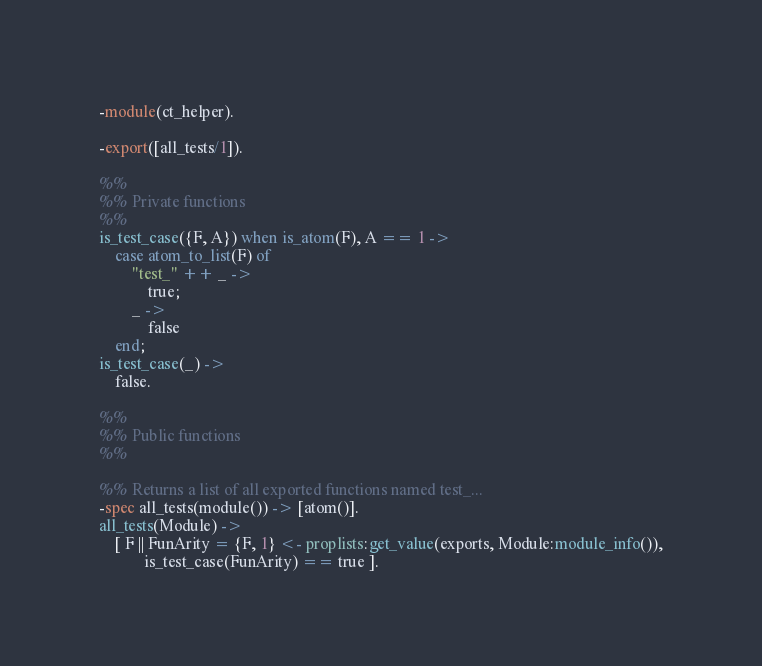<code> <loc_0><loc_0><loc_500><loc_500><_Erlang_>-module(ct_helper).

-export([all_tests/1]).

%%
%% Private functions
%%
is_test_case({F, A}) when is_atom(F), A == 1 ->
    case atom_to_list(F) of
        "test_" ++ _ ->
            true;
        _ ->
            false
    end;
is_test_case(_) ->
    false.

%%
%% Public functions
%%

%% Returns a list of all exported functions named test_...
-spec all_tests(module()) -> [atom()].
all_tests(Module) ->
    [ F || FunArity = {F, 1} <- proplists:get_value(exports, Module:module_info()),
           is_test_case(FunArity) == true ].
</code> 